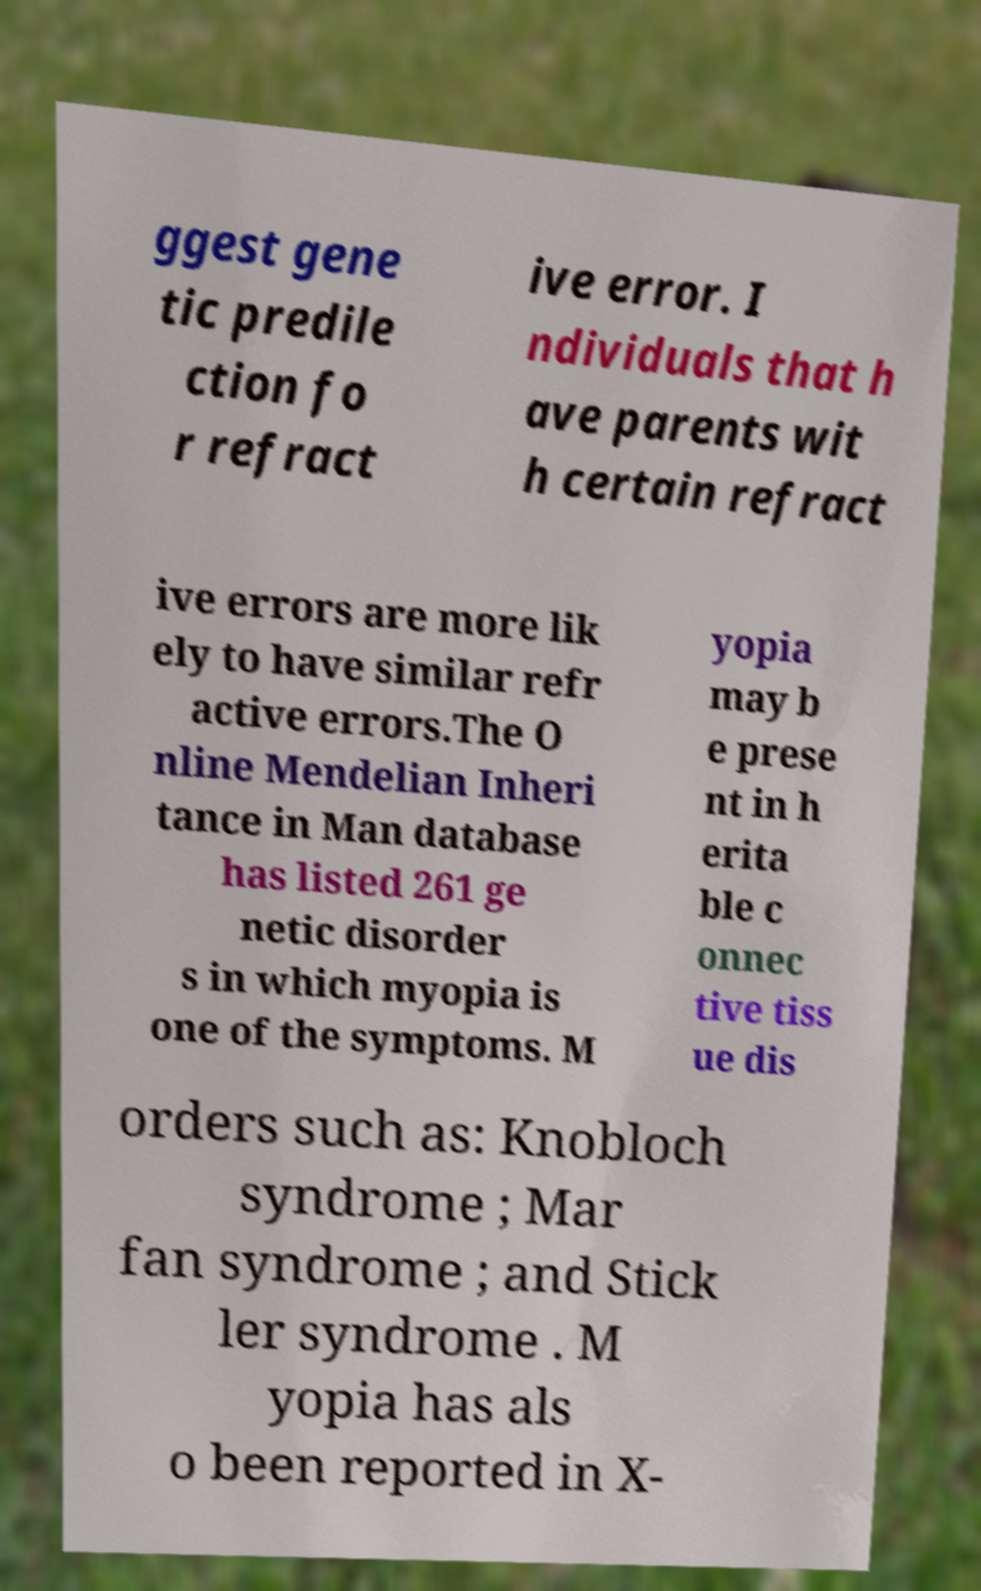For documentation purposes, I need the text within this image transcribed. Could you provide that? ggest gene tic predile ction fo r refract ive error. I ndividuals that h ave parents wit h certain refract ive errors are more lik ely to have similar refr active errors.The O nline Mendelian Inheri tance in Man database has listed 261 ge netic disorder s in which myopia is one of the symptoms. M yopia may b e prese nt in h erita ble c onnec tive tiss ue dis orders such as: Knobloch syndrome ; Mar fan syndrome ; and Stick ler syndrome . M yopia has als o been reported in X- 